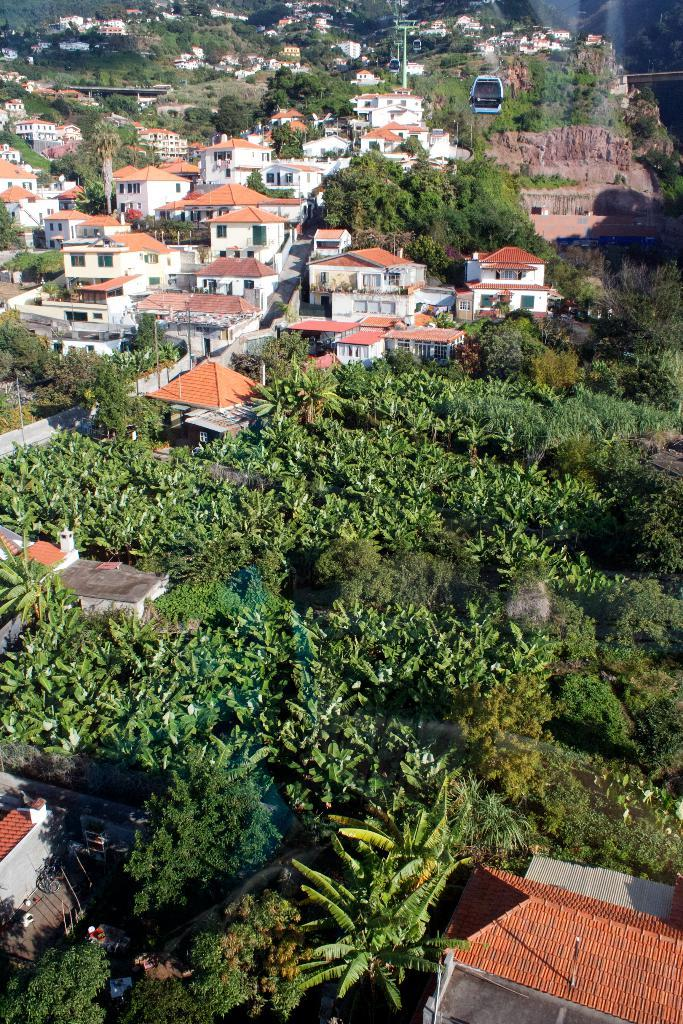What type of structures can be seen in the image? There are buildings in the image. What other natural elements are present in the image? There are trees in the image. What color are the roofs of the buildings? The roofs of the buildings are orange. What type of vegetation is present on the ground in the image? There are plants on the ground in the bottom of the image. Can you see a maid wearing a cap and necklace in the image? There is no maid, cap, or necklace present in the image. 